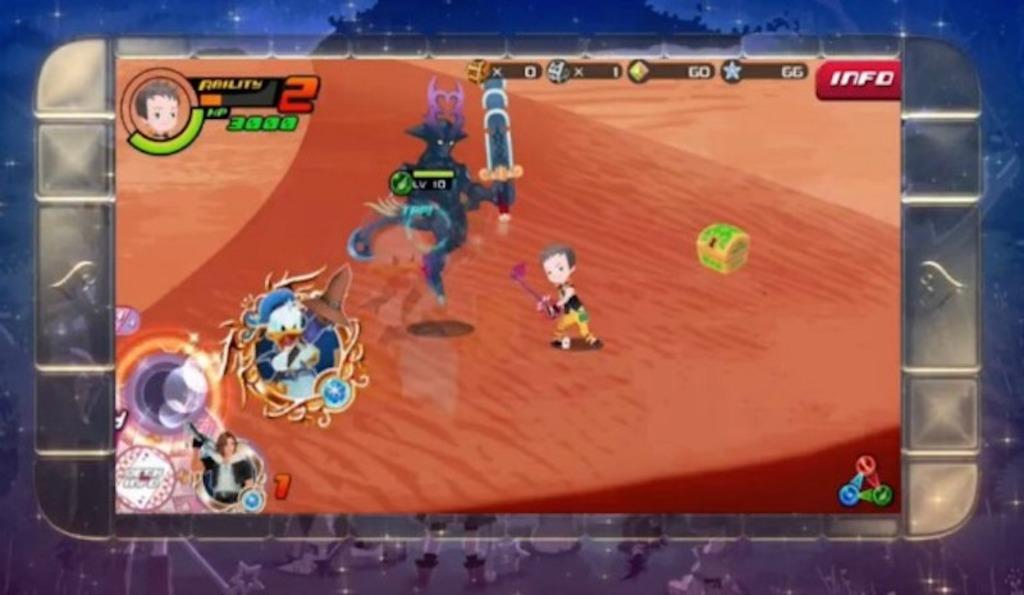What type of media is the image from? The image is from an animated video game. Can you describe the main character in the image? There is a person in the middle of the image. What other character or object can be seen on the left side of the image? There is a duck on the left side of the image. What type of badge is the person wearing in the image? There is no badge visible on the person in the image. How many cakes are present on the right side of the image? There is no mention of cakes in the provided facts, and therefore no cakes are present in the image. 